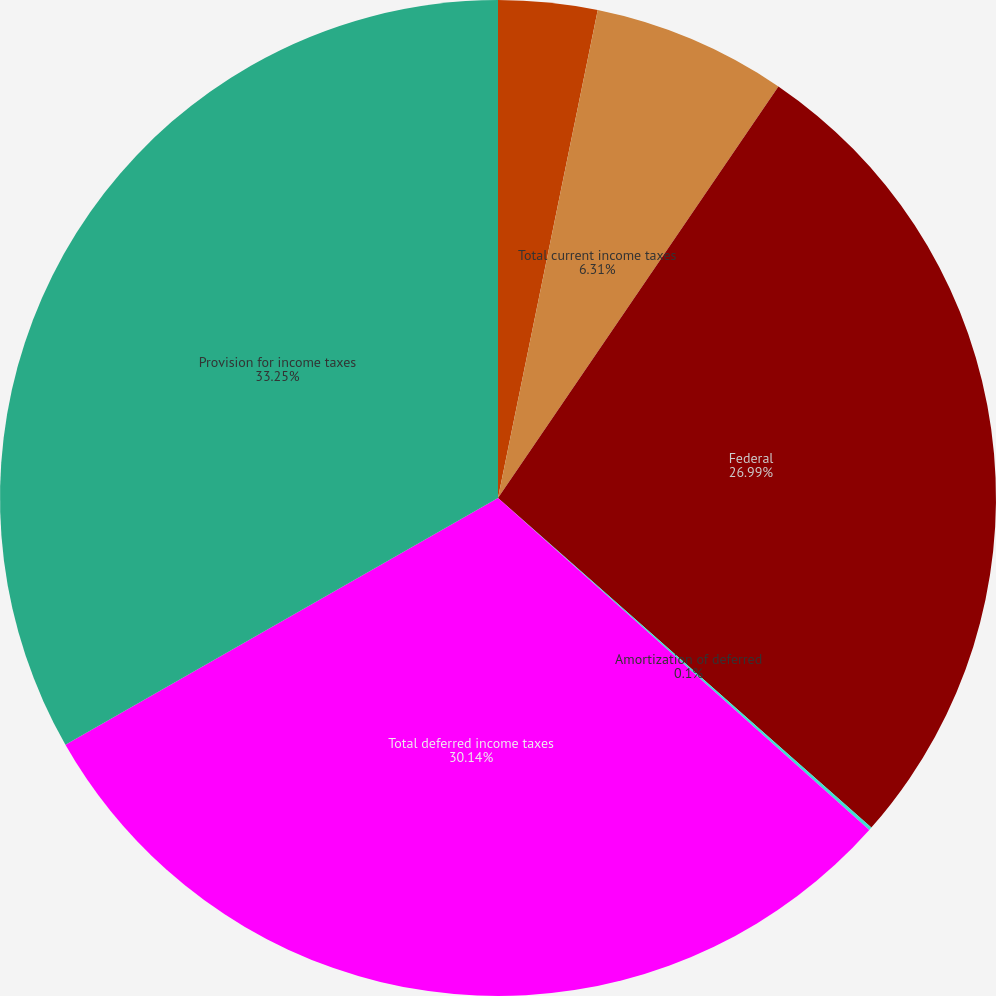Convert chart to OTSL. <chart><loc_0><loc_0><loc_500><loc_500><pie_chart><fcel>State<fcel>Total current income taxes<fcel>Federal<fcel>Amortization of deferred<fcel>Total deferred income taxes<fcel>Provision for income taxes<nl><fcel>3.21%<fcel>6.31%<fcel>26.99%<fcel>0.1%<fcel>30.14%<fcel>33.25%<nl></chart> 